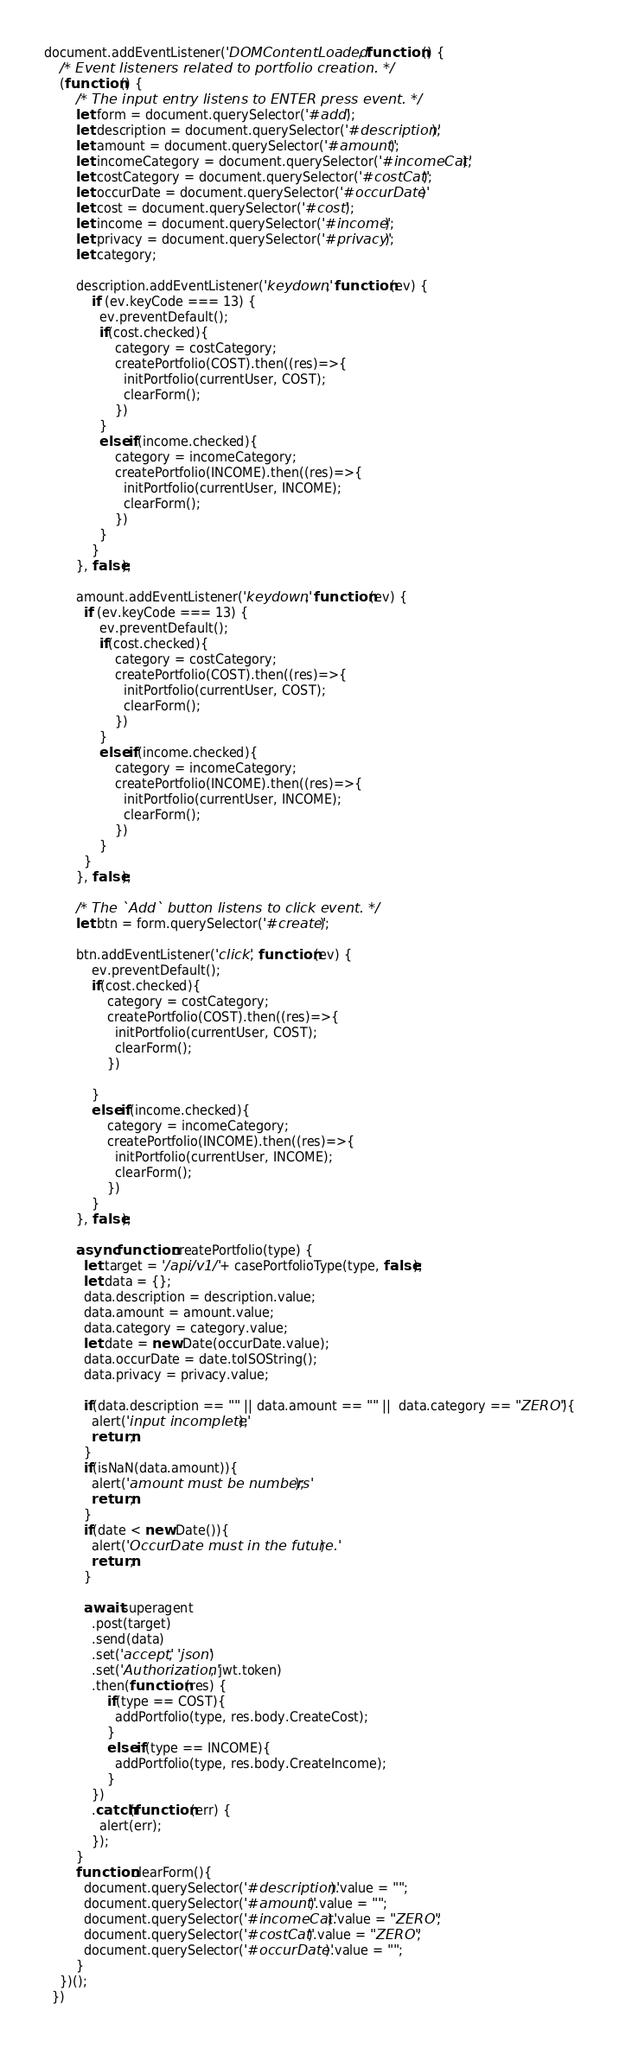Convert code to text. <code><loc_0><loc_0><loc_500><loc_500><_JavaScript_>document.addEventListener('DOMContentLoaded', function () {
    /* Event listeners related to portfolio creation. */
    (function () {
        /* The input entry listens to ENTER press event. */
        let form = document.querySelector('#add');
        let description = document.querySelector('#description');
        let amount = document.querySelector('#amount');
        let incomeCategory = document.querySelector('#incomeCat');
        let costCategory = document.querySelector('#costCat');
        let occurDate = document.querySelector('#occurDate')
        let cost = document.querySelector('#cost');
        let income = document.querySelector('#income');
        let privacy = document.querySelector('#privacy');
        let category;
        
        description.addEventListener('keydown', function (ev) {
            if (ev.keyCode === 13) {
              ev.preventDefault();
              if(cost.checked){
                  category = costCategory;
                  createPortfolio(COST).then((res)=>{
                    initPortfolio(currentUser, COST);
                    clearForm();
                  })
              }
              else if(income.checked){
                  category = incomeCategory;
                  createPortfolio(INCOME).then((res)=>{
                    initPortfolio(currentUser, INCOME);
                    clearForm();
                  })
              }  
            }
        }, false);
  
        amount.addEventListener('keydown', function (ev) {
          if (ev.keyCode === 13) {
              ev.preventDefault();
              if(cost.checked){
                  category = costCategory;
                  createPortfolio(COST).then((res)=>{
                    initPortfolio(currentUser, COST);
                    clearForm();
                  })
              }
              else if(income.checked){
                  category = incomeCategory;
                  createPortfolio(INCOME).then((res)=>{
                    initPortfolio(currentUser, INCOME);
                    clearForm();
                  })
              }
          }
        }, false);
  
        /* The `Add` button listens to click event. */
        let btn = form.querySelector('#create');
  
        btn.addEventListener('click', function (ev) {
            ev.preventDefault();
            if(cost.checked){
                category = costCategory;
                createPortfolio(COST).then((res)=>{
                  initPortfolio(currentUser, COST);
                  clearForm();
                })
                
            }
            else if(income.checked){
                category = incomeCategory;
                createPortfolio(INCOME).then((res)=>{
                  initPortfolio(currentUser, INCOME);
                  clearForm();
                })
            }
        }, false);
  
        async function createPortfolio(type) {
          let target = '/api/v1/' + casePortfolioType(type, false);
          let data = {};
          data.description = description.value;
          data.amount = amount.value;
          data.category = category.value;
          let date = new Date(occurDate.value);
          data.occurDate = date.toISOString();
          data.privacy = privacy.value;
  
          if(data.description == "" || data.amount == "" ||  data.category == "ZERO"){
            alert('input incomplete');
            return;
          }
          if(isNaN(data.amount)){
            alert('amount must be numbers');
            return;
          }
          if(date < new Date()){
            alert('OccurDate must in the future.')
            return;
          }
              
          await superagent
            .post(target)
            .send(data)
            .set('accept', 'json')
            .set('Authorization', jwt.token)
            .then(function (res) {          
                if(type == COST){
                  addPortfolio(type, res.body.CreateCost);
                }
                else if(type == INCOME){
                  addPortfolio(type, res.body.CreateIncome);
                }
            })
            .catch(function (err) {
              alert(err);
            });
        }
        function clearForm(){
          document.querySelector('#description').value = "";
          document.querySelector('#amount').value = "";
          document.querySelector('#incomeCat').value = "ZERO";
          document.querySelector('#costCat').value = "ZERO";
          document.querySelector('#occurDate').value = "";
        }
    })();
  })</code> 